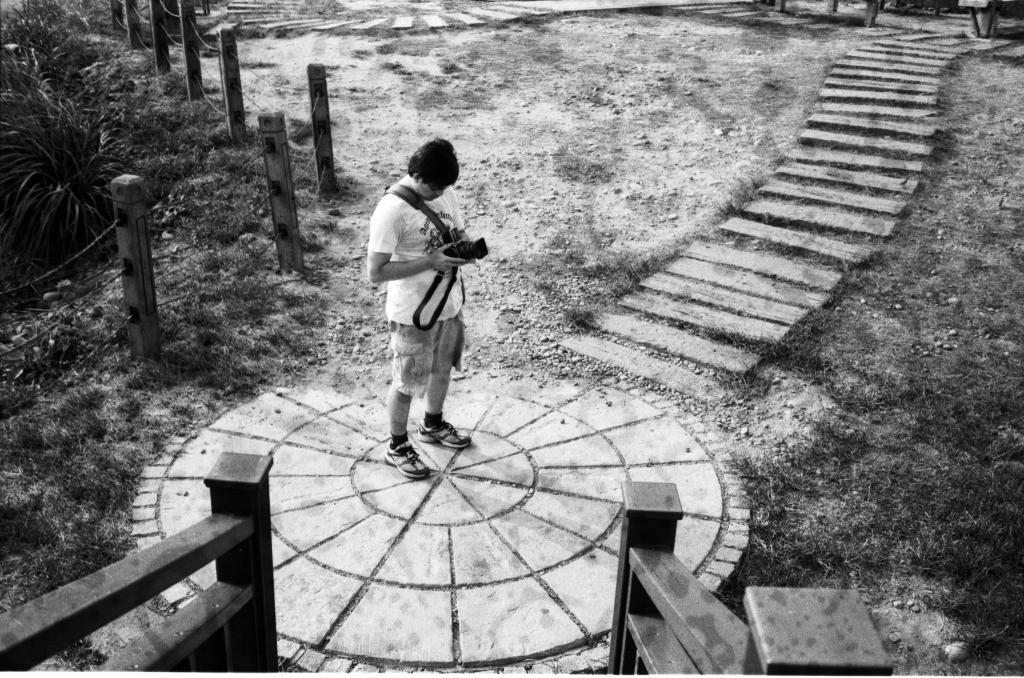What is the color scheme of the image? The image is black and white. What is the man in the image doing? The man is standing on a path and holding a camera. What can be seen in the background of the image? There are poles with ropes and plants in the background. What type of hair can be seen on the man's leg in the image? There is no hair visible on the man's leg in the image, as it is a black and white photograph. How many windows are visible in the image? There are no windows visible in the image; it features a man standing on a path with a camera and a background of poles with ropes and plants. 